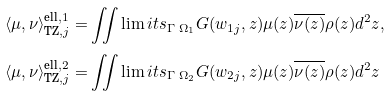Convert formula to latex. <formula><loc_0><loc_0><loc_500><loc_500>\langle \mu , \nu \rangle ^ { \text {ell} , 1 } _ { \text {TZ} , j } = & \iint \lim i t s _ { \Gamma \ \Omega _ { 1 } } G ( w _ { 1 j } , z ) \mu ( z ) \overline { \nu ( z ) } \rho ( z ) d ^ { 2 } z , \\ \langle \mu , \nu \rangle ^ { \text {ell} , 2 } _ { \text {TZ} , j } = & \iint \lim i t s _ { \Gamma \ \Omega _ { 2 } } G ( w _ { 2 j } , z ) \mu ( z ) \overline { \nu ( z ) } \rho ( z ) d ^ { 2 } z</formula> 